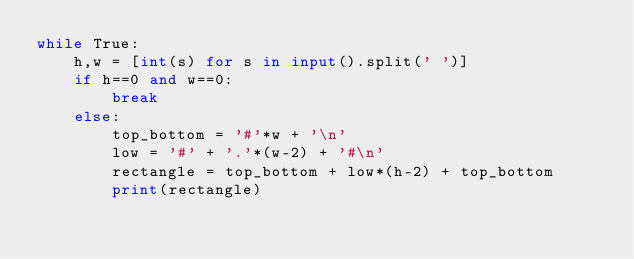<code> <loc_0><loc_0><loc_500><loc_500><_Python_>while True:
	h,w = [int(s) for s in input().split(' ')]
	if h==0 and w==0:
		break
	else:
		top_bottom = '#'*w + '\n'
		low = '#' + '.'*(w-2) + '#\n'
		rectangle = top_bottom + low*(h-2) + top_bottom
		print(rectangle)</code> 